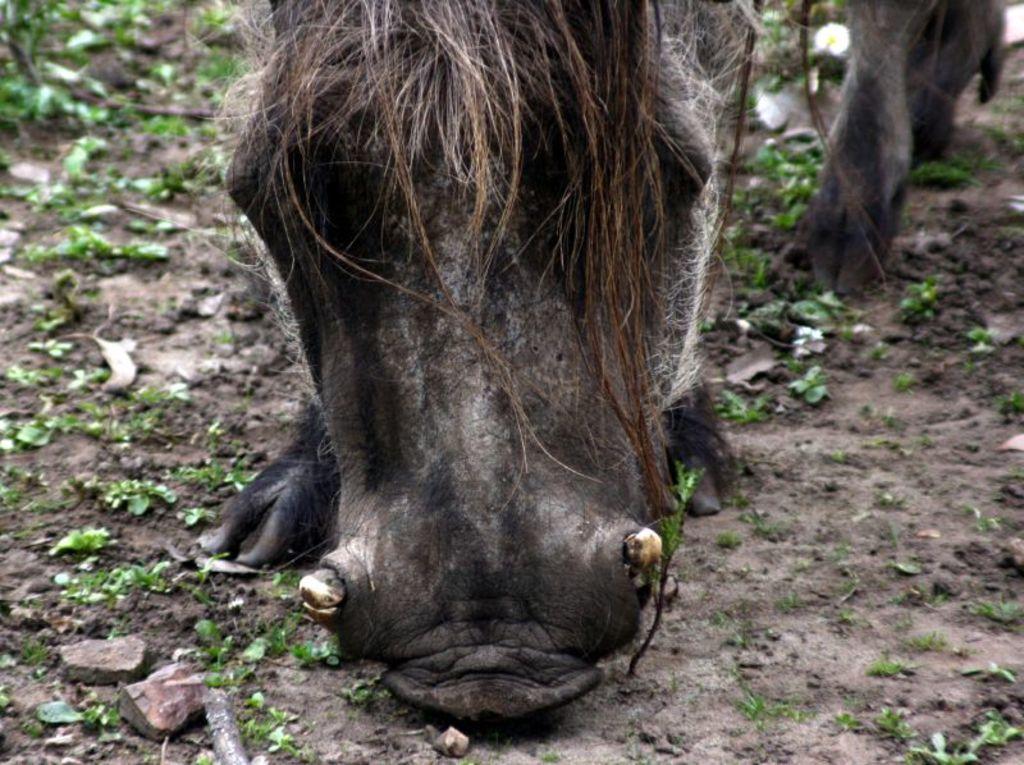Describe this image in one or two sentences. In this image, we can see an animal and at the bottom, there are stones and some plants on the ground. 